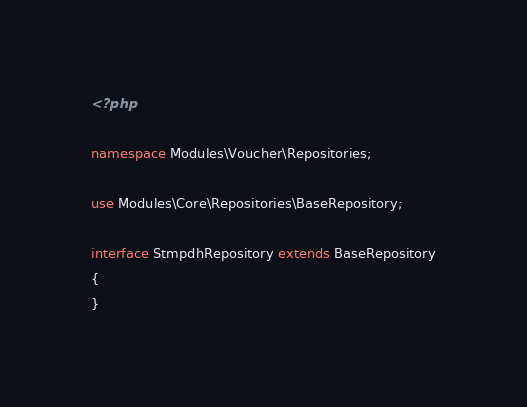Convert code to text. <code><loc_0><loc_0><loc_500><loc_500><_PHP_><?php

namespace Modules\Voucher\Repositories;

use Modules\Core\Repositories\BaseRepository;

interface StmpdhRepository extends BaseRepository
{
}
</code> 